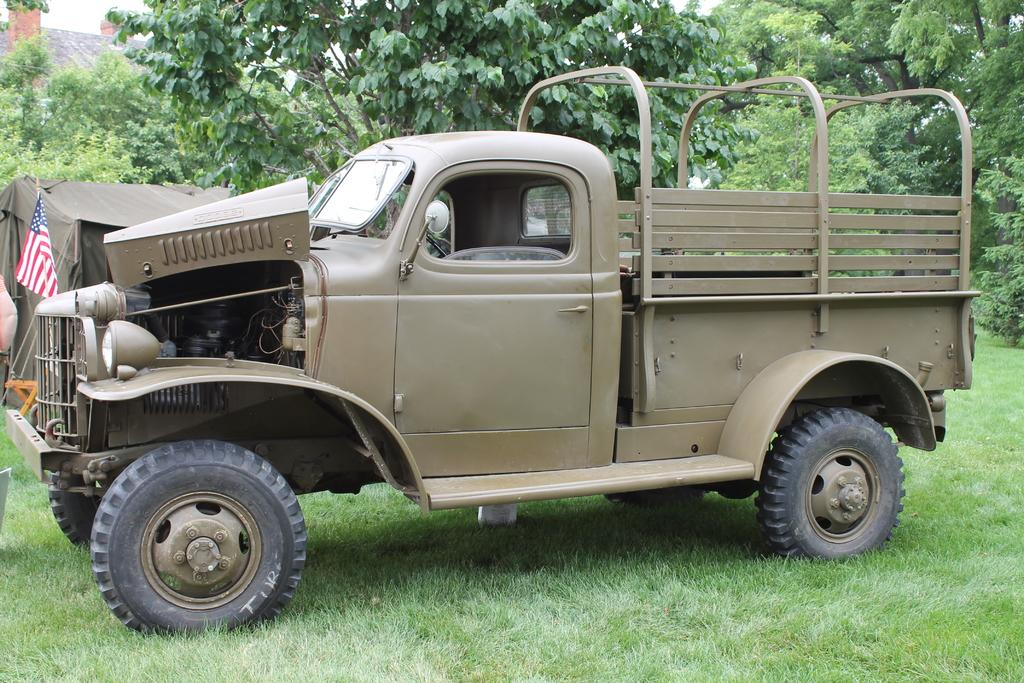What is located on the grass in the image? There is a vehicle on the grass in the image. What can be seen in the background of the image? In the background, there is a tent, ropes, a flag, trees, a house, and the sky. Can you describe the object on the left side of the image? Unfortunately, the provided facts do not mention any specific object on the left side of the image. What does the caption on the wind say in the image? There is no caption or wind present in the image. 